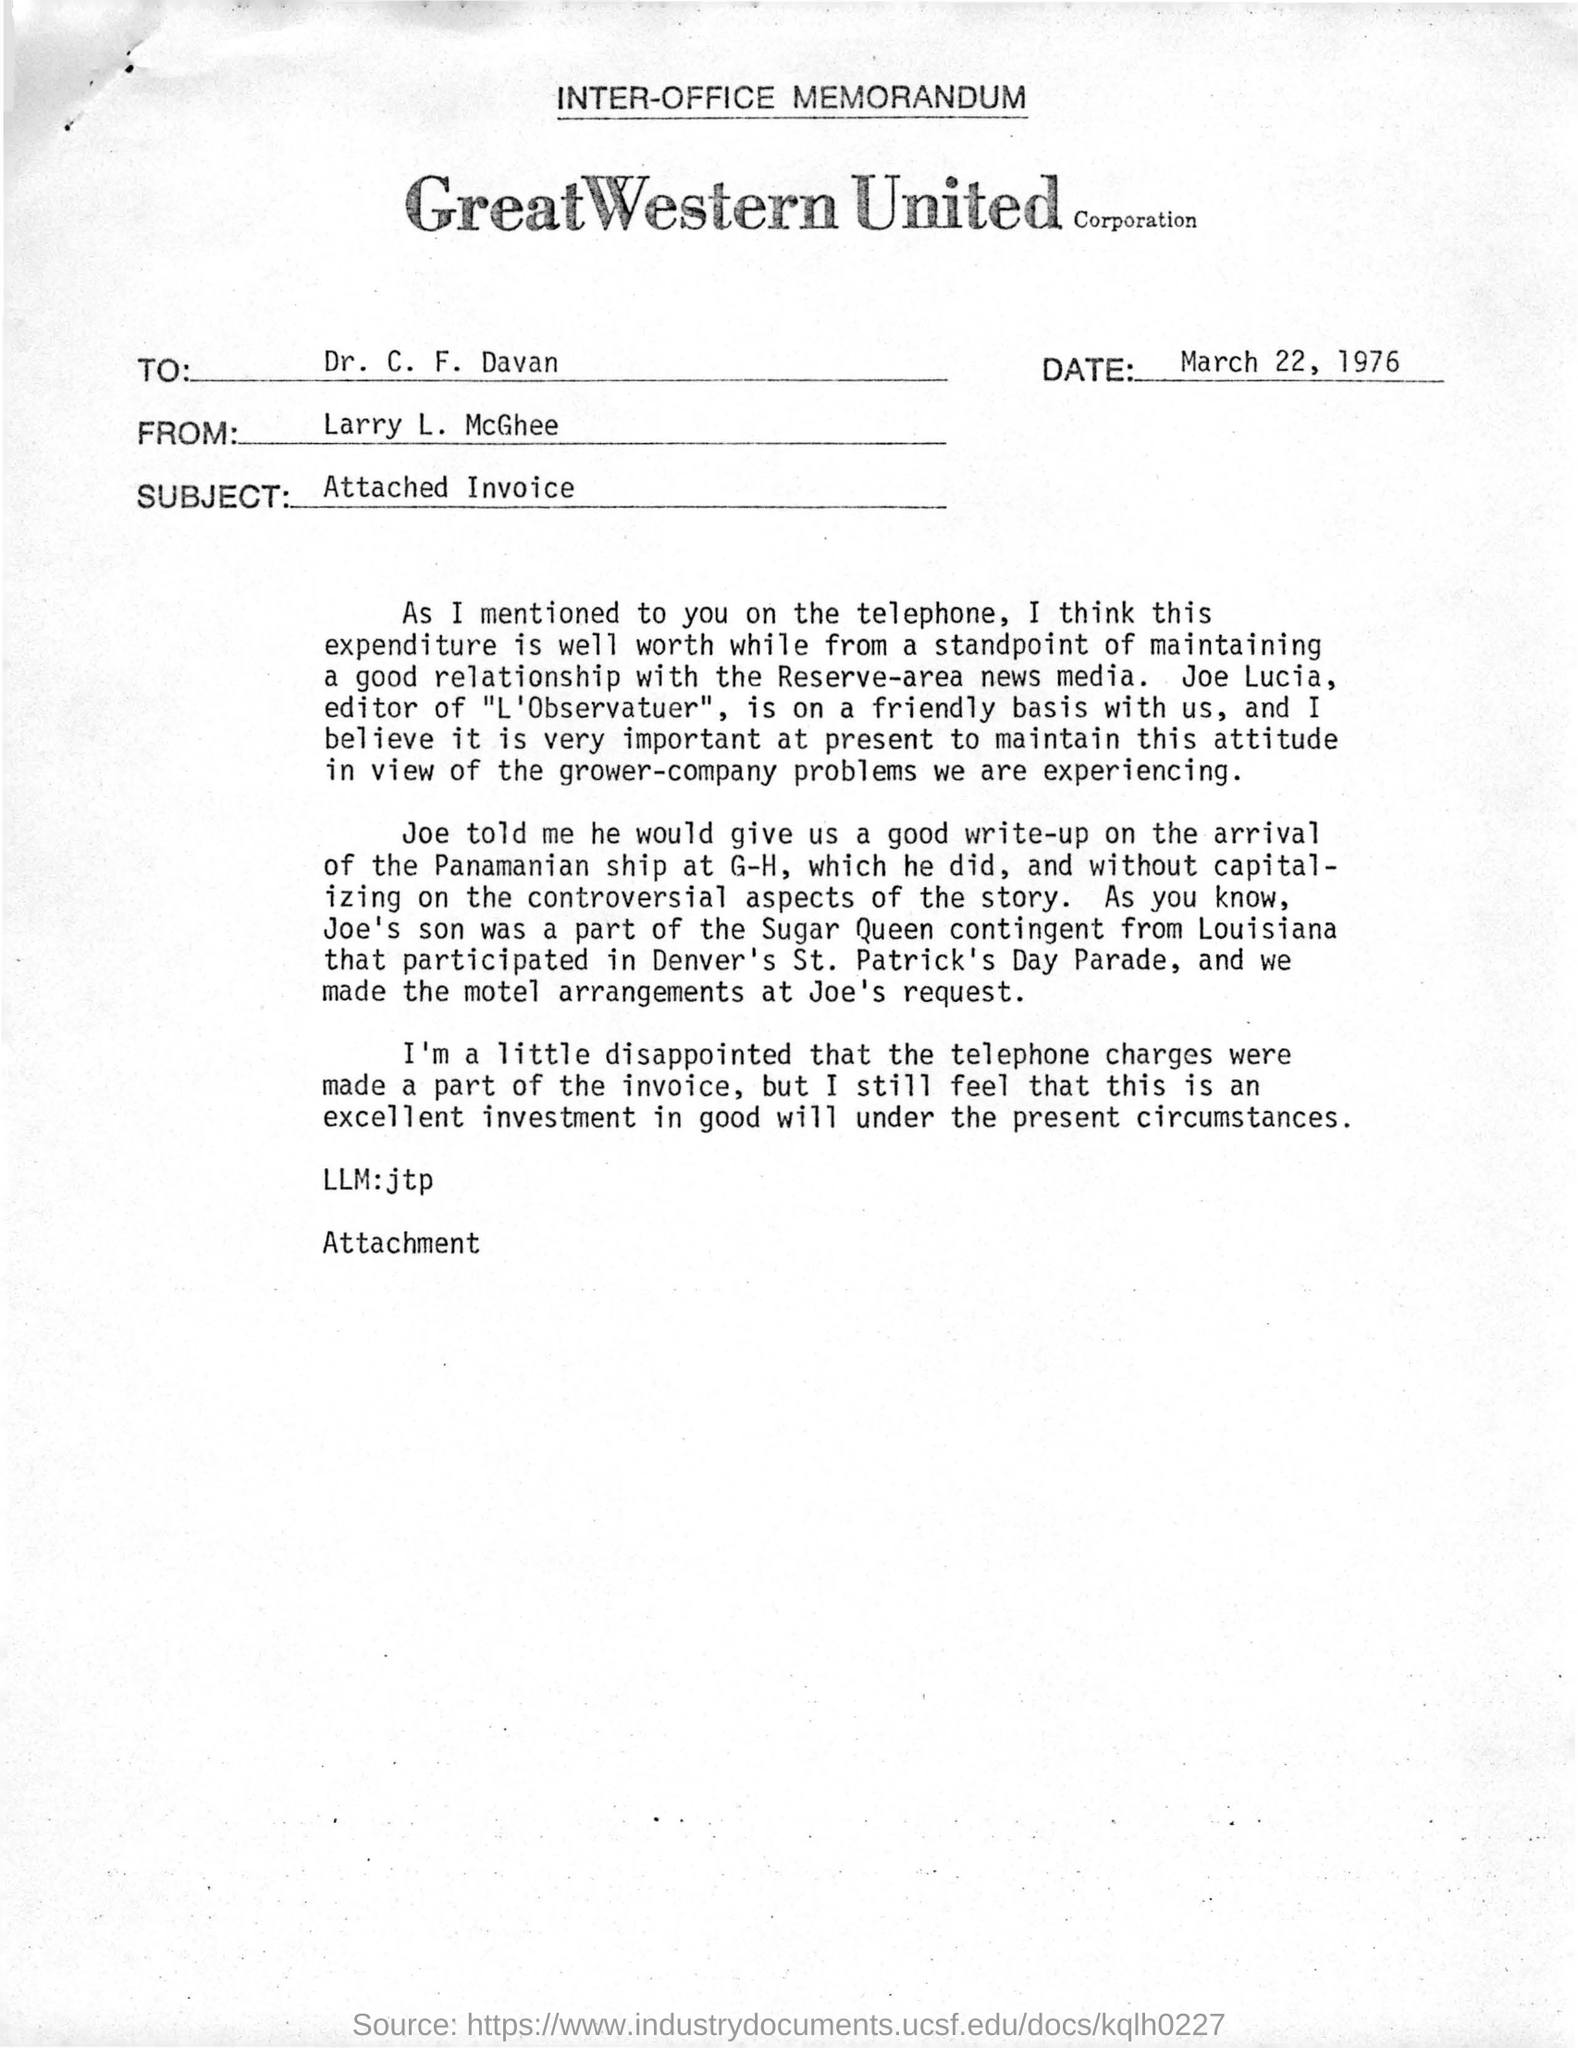What is the company name mentioned in this document?
Your answer should be compact. Great western united corporation. What type of document it is?
Ensure brevity in your answer.  Inter-office memorandum. What is the date in this document?
Give a very brief answer. March 22, 1976. To whom this document addressed?
Ensure brevity in your answer.  Dr. C. F. Davan. Who's is the sender in this document?
Make the answer very short. Larry L. McGhee. What is the subject mentioned in this document?
Offer a very short reply. Attached Invoice. 